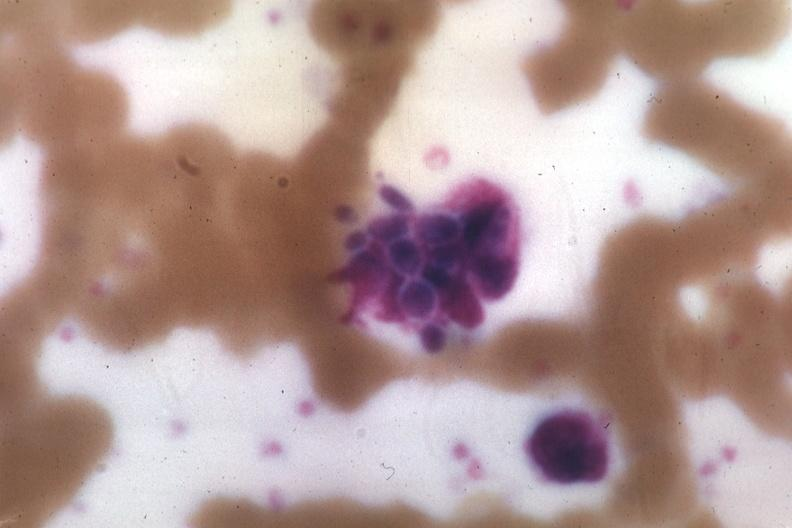does this image show wrights yeast forms?
Answer the question using a single word or phrase. Yes 